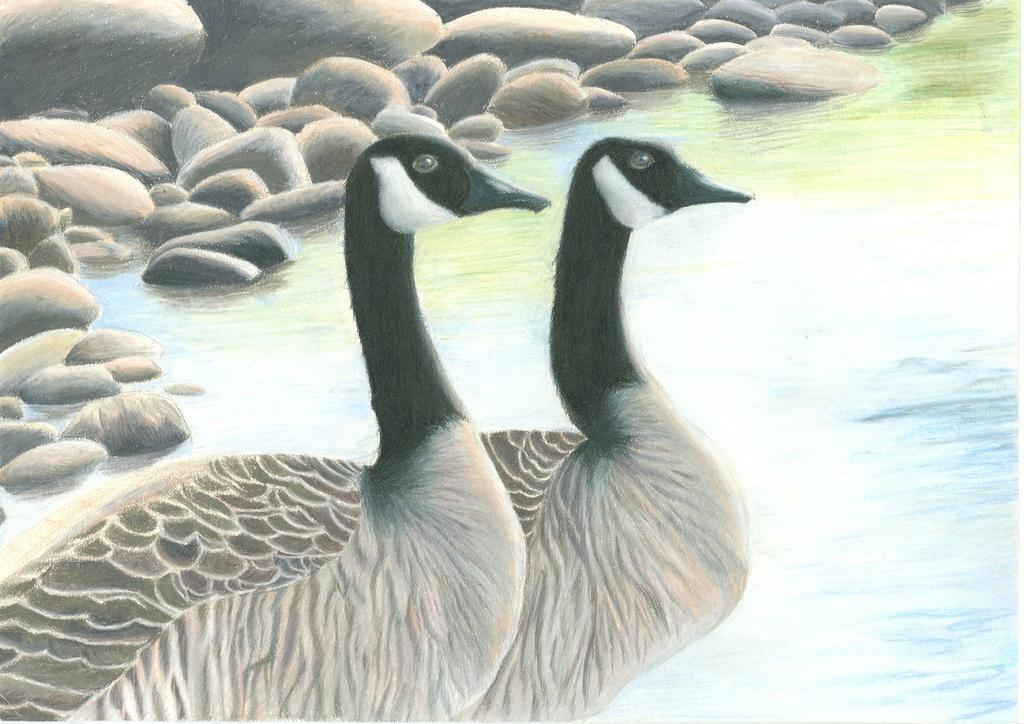In one or two sentences, can you explain what this image depicts? In this image I can see two birds in black, brown and white color. Background I can see few stones. 